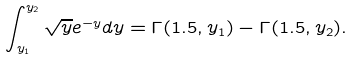<formula> <loc_0><loc_0><loc_500><loc_500>\int _ { y _ { 1 } } ^ { y _ { 2 } } \sqrt { y } e ^ { - y } d y = \Gamma ( 1 . 5 , y _ { 1 } ) - \Gamma ( 1 . 5 , y _ { 2 } ) .</formula> 